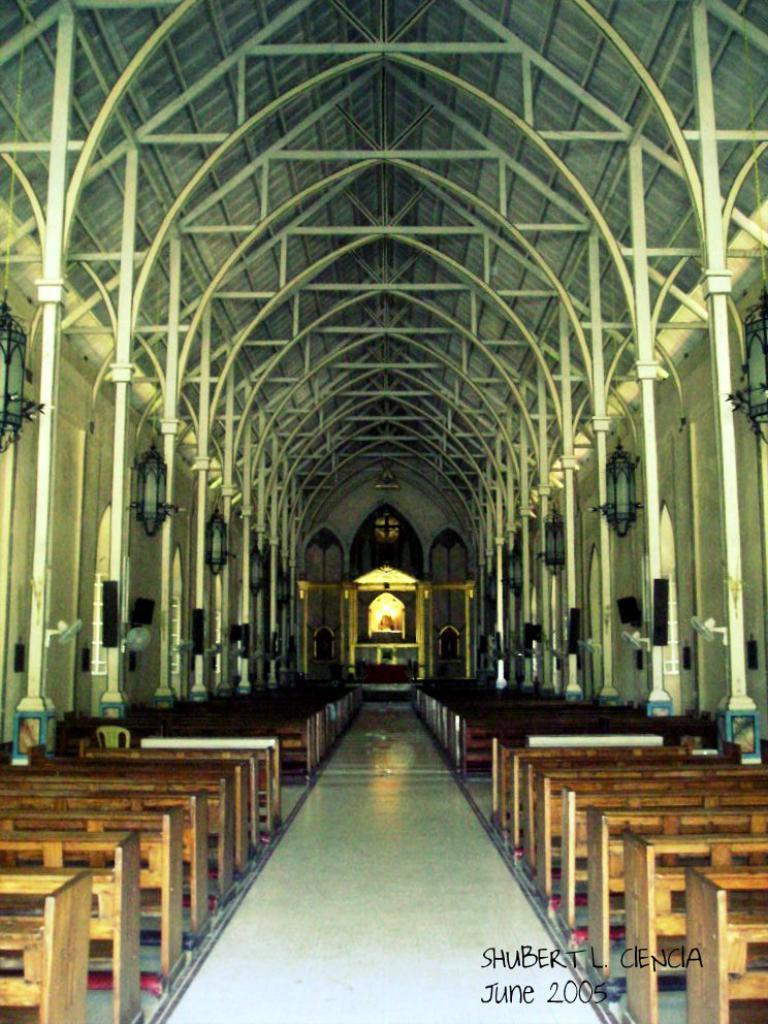<image>
Write a terse but informative summary of the picture. A photo of the inside of a church was taken in June 2005. 